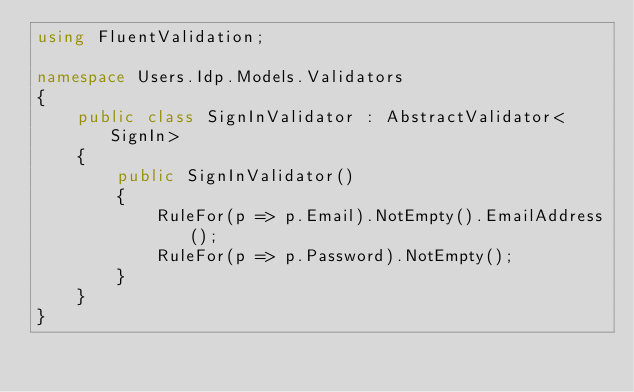<code> <loc_0><loc_0><loc_500><loc_500><_C#_>using FluentValidation;

namespace Users.Idp.Models.Validators
{
    public class SignInValidator : AbstractValidator<SignIn>
    {
        public SignInValidator()
        {
            RuleFor(p => p.Email).NotEmpty().EmailAddress();
            RuleFor(p => p.Password).NotEmpty();
        }
    }
}</code> 